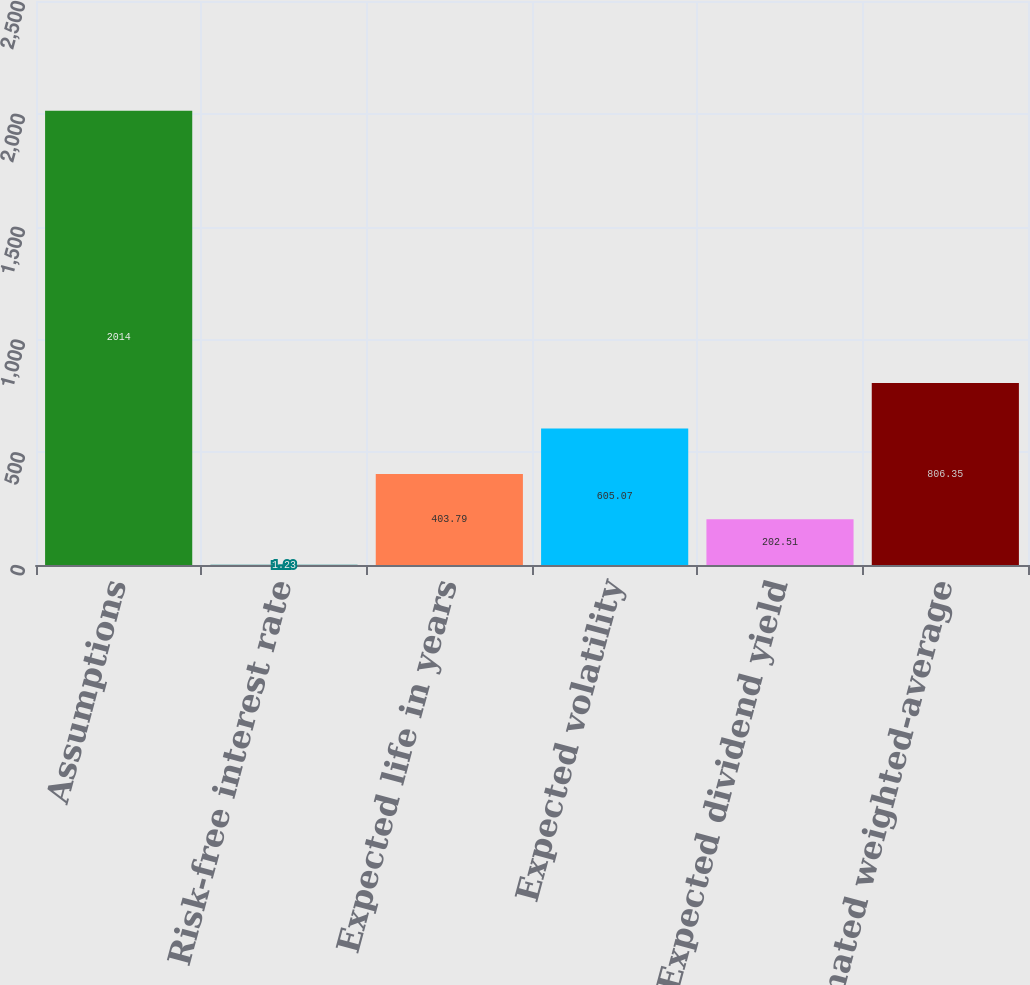<chart> <loc_0><loc_0><loc_500><loc_500><bar_chart><fcel>Assumptions<fcel>Risk-free interest rate<fcel>Expected life in years<fcel>Expected volatility<fcel>Expected dividend yield<fcel>Estimated weighted-average<nl><fcel>2014<fcel>1.23<fcel>403.79<fcel>605.07<fcel>202.51<fcel>806.35<nl></chart> 